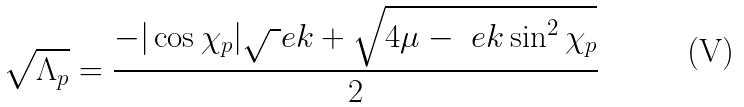<formula> <loc_0><loc_0><loc_500><loc_500>\sqrt { \Lambda _ { p } } = \frac { - | \cos \chi _ { p } | \sqrt { \ } e k + \sqrt { 4 \mu - \ e k \sin ^ { 2 } \chi _ { p } } } 2</formula> 